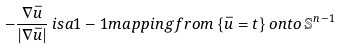<formula> <loc_0><loc_0><loc_500><loc_500>- \frac { \nabla \bar { u } } { | \nabla \bar { u } | } \, i s a 1 - 1 m a p p i n g f r o m \, \{ \bar { u } = t \} \, o n t o \, \mathbb { S } ^ { n - 1 }</formula> 